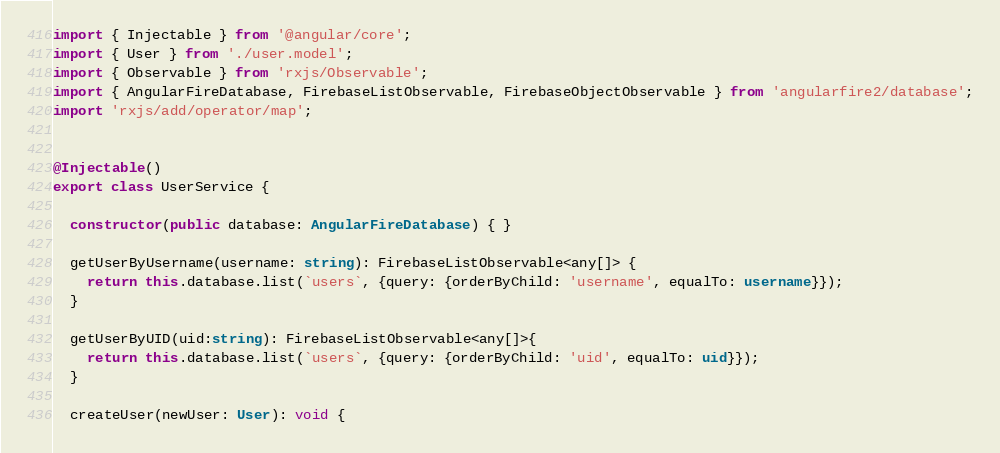Convert code to text. <code><loc_0><loc_0><loc_500><loc_500><_TypeScript_>import { Injectable } from '@angular/core';
import { User } from './user.model';
import { Observable } from 'rxjs/Observable';
import { AngularFireDatabase, FirebaseListObservable, FirebaseObjectObservable } from 'angularfire2/database';
import 'rxjs/add/operator/map';


@Injectable()
export class UserService {

  constructor(public database: AngularFireDatabase) { }

  getUserByUsername(username: string): FirebaseListObservable<any[]> {
    return this.database.list(`users`, {query: {orderByChild: 'username', equalTo: username}});
  }

  getUserByUID(uid:string): FirebaseListObservable<any[]>{
    return this.database.list(`users`, {query: {orderByChild: 'uid', equalTo: uid}});
  }

  createUser(newUser: User): void {</code> 